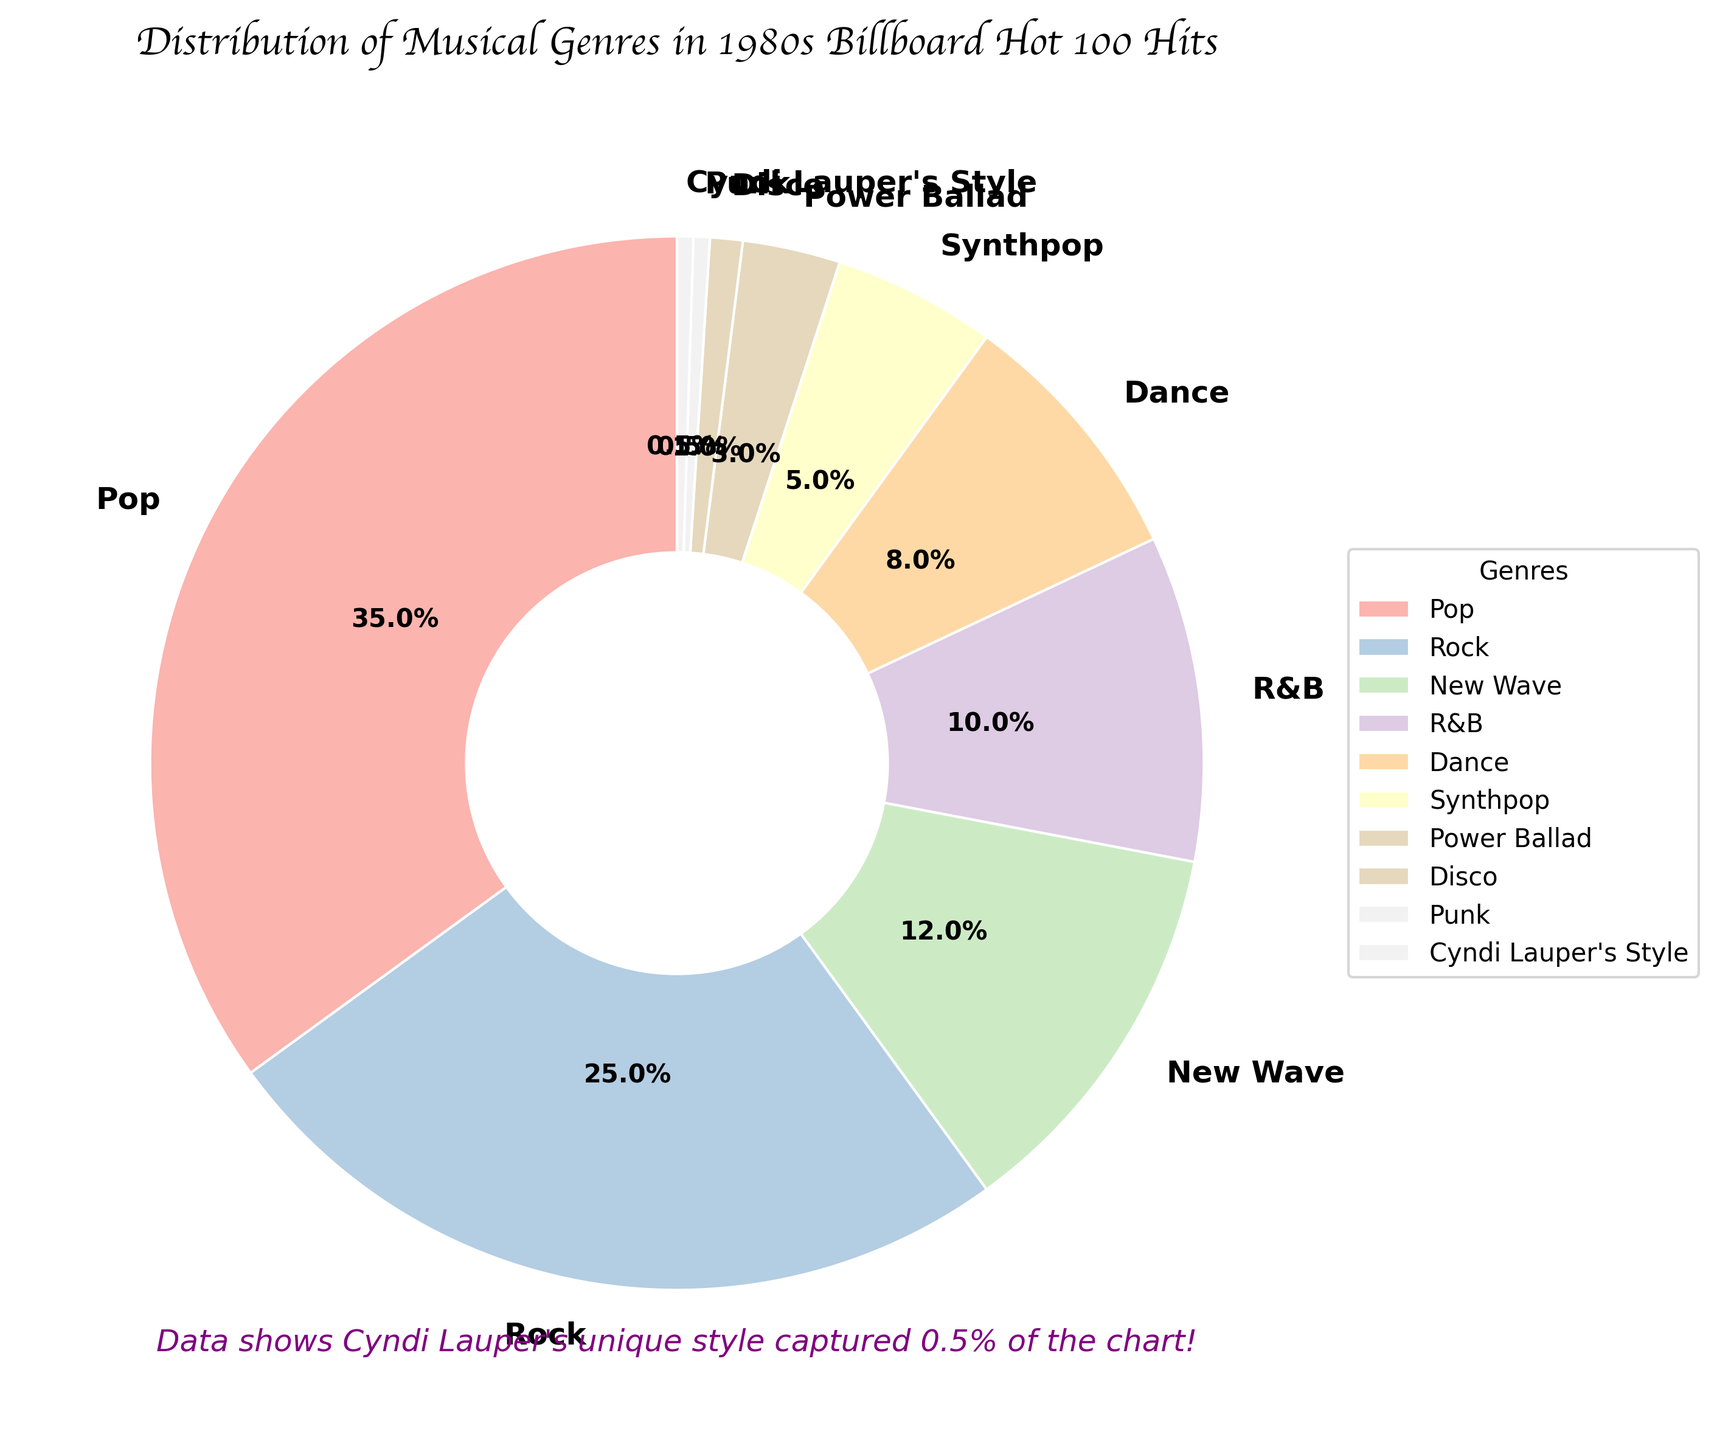Which genre has the highest percentage in the 1980s Billboard Hot 100 hits? Identify the largest wedge in the pie chart. The wedge labeled "Pop" has the largest size with 35%.
Answer: Pop How much more percentage does Rock have than Synthpop? Subtract the percentage of Synthpop (5%) from the percentage of Rock (25%). The difference is 25% - 5% = 20%.
Answer: 20% What is the combined percentage of New Wave and Dance genres? Add the percentages of New Wave (12%) and Dance (8%). The sum is 12% + 8% = 20%.
Answer: 20% How does the percentage of R&B compare to that of Dance? Compare the percentages of R&B (10%) and Dance (8%). Since 10% is greater than 8%, R&B has a higher percentage than Dance.
Answer: R&B is higher What is the combined percentage of the least represented genres? Add the percentages of Power Ballad (3%), Disco (1%), Punk (0.5%), and Cyndi Lauper's Style (0.5%). The sum is 3% + 1% + 0.5% + 0.5% = 5%.
Answer: 5% How much more popular is Pop compared to the total of Synthpop and Power Ballad? First, find the combined percentage of Synthpop (5%) and Power Ballad (3%), which is 5% + 3% = 8%. Then, subtract this from the percentage of Pop (35%). The difference is 35% - 8% = 27%.
Answer: 27% Which genre has almost the same representation as Cyndi Lauper's Style? Identify the genre with a similar percentage to Cyndi Lauper's Style (0.5%). The genre Punk also has 0.5%.
Answer: Punk What's the visual characteristic of the wedges in the pie chart? Describe the wedges' appearance in terms of shape and orientation. The wedges are wide with smooth edges and start at an angle of 90 degrees, enclosed by white borders.
Answer: Wide, smooth wedges starting at 90 degrees with white borders What is the total percentage of Rock, Synthpop, and R&B combined? Sum the percentages of Rock (25%), Synthpop (5%), and R&B (10%). The total is 25% + 5% + 10% = 40%.
Answer: 40% What is the smallest percentage represented in the chart? Identify the wedge with the smallest value. Both Cyndi Lauper's Style and Punk have the smallest value of 0.5%.
Answer: 0.5% 